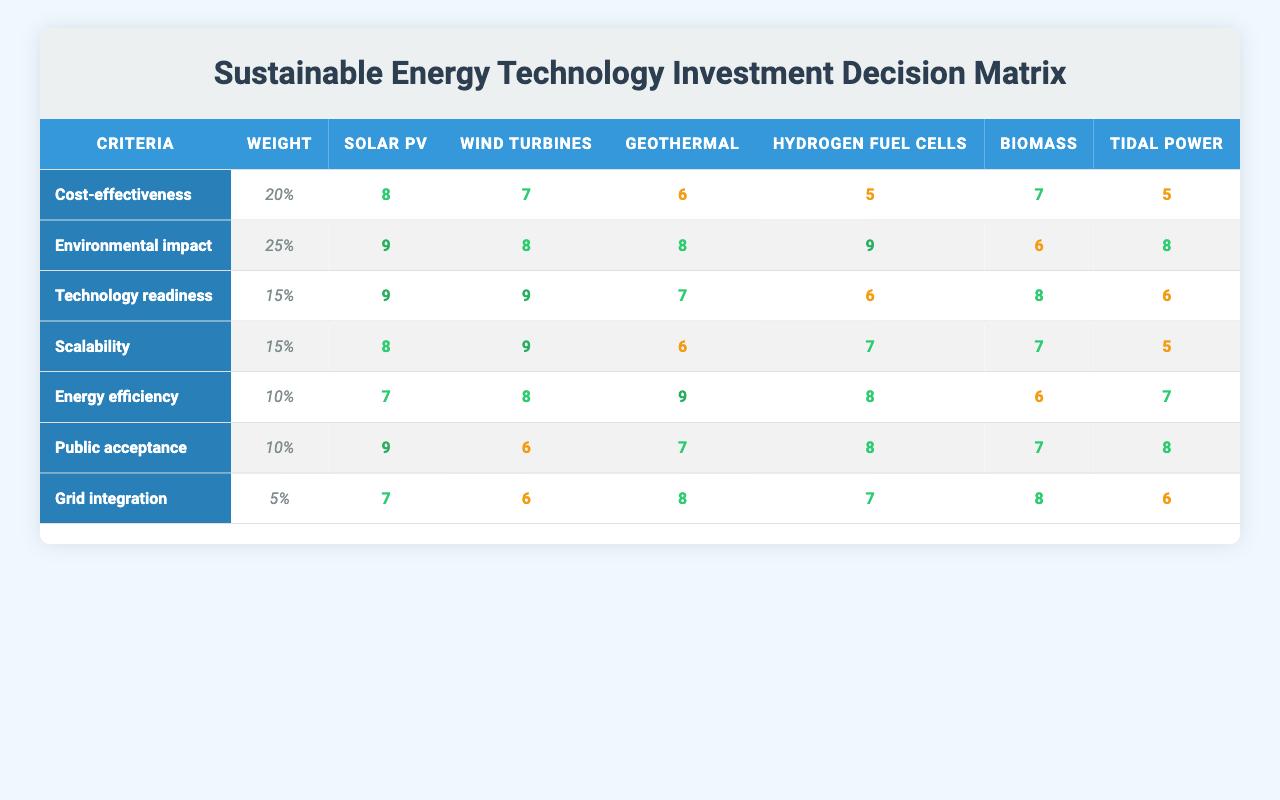What is the environmental impact score of solar photovoltaic? By locating the row for "Environmental impact" and the corresponding column for "Solar PV," the score is found to be 9.
Answer: 9 Which energy technology has the highest score for cost-effectiveness? The cost-effectiveness scores for each technology are as follows: Solar photovoltaic (8), Wind turbines (7), Geothermal power (6), Hydrogen fuel cells (5), Biomass energy (7), Tidal power (5). The highest score of 8 belongs to Solar photovoltaic.
Answer: Solar photovoltaic What is the average energy efficiency score across all technologies? The scores for energy efficiency are: Solar PV (7), Wind turbines (8), Geothermal (9), Hydrogen fuel cells (8), Biomass (6), Tidal power (7). Summing these gives 7 + 8 + 9 + 8 + 6 + 7 = 45. Dividing by the number of technologies (6) results in an average of 45/6 = 7.5.
Answer: 7.5 Do wind turbines demonstrate better scalability than geothermal power? The scores for wind turbines in scalability is 9, whereas geothermal power scores 6. Thus, wind turbines have a higher score.
Answer: Yes Which technology has the lowest score for grid integration? The scores for grid integration are: Solar PV (7), Wind turbines (6), Geothermal (8), Hydrogen fuel cells (7), Biomass (8), Tidal power (6). The lowest score is 6, which is shared by Wind turbines and Tidal power.
Answer: Wind turbines and Tidal power What is the total weight allocated to the top three criteria based on their importance? The weights for the top three criteria are as follows: Environmental impact (25%), Cost-effectiveness (20%), and Technology readiness (15%). Summing these yields 25 + 20 + 15 = 60%.
Answer: 60% Which technology ranks highest in public acceptance? The scores for public acceptance are: Solar PV (9), Wind turbines (6), Geothermal (7), Hydrogen fuel cells (8), Biomass (7), Tidal power (8). The highest score is 9 for Solar PV.
Answer: Solar photovoltaic How does the scalability score of Geothermal power compare to Hydrogen fuel cells? The scores indicate that Geothermal power has a score of 6 for scalability while Hydrogen fuel cells score 7. Hydrogen fuel cells have a higher score.
Answer: Hydrogen fuel cells What is the difference between the highest and lowest scores for environmental impact? The highest score for environmental impact is 9 (Solar PV and Hydrogen fuel cells), and the lowest score is 6 (Biomass energy). The difference is 9 - 6 = 3.
Answer: 3 